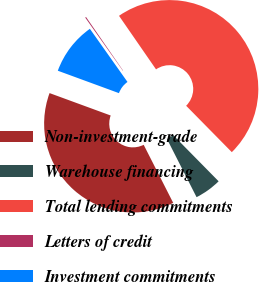<chart> <loc_0><loc_0><loc_500><loc_500><pie_chart><fcel>Non-investment-grade<fcel>Warehouse financing<fcel>Total lending commitments<fcel>Letters of credit<fcel>Investment commitments<nl><fcel>38.08%<fcel>4.89%<fcel>47.25%<fcel>0.18%<fcel>9.6%<nl></chart> 